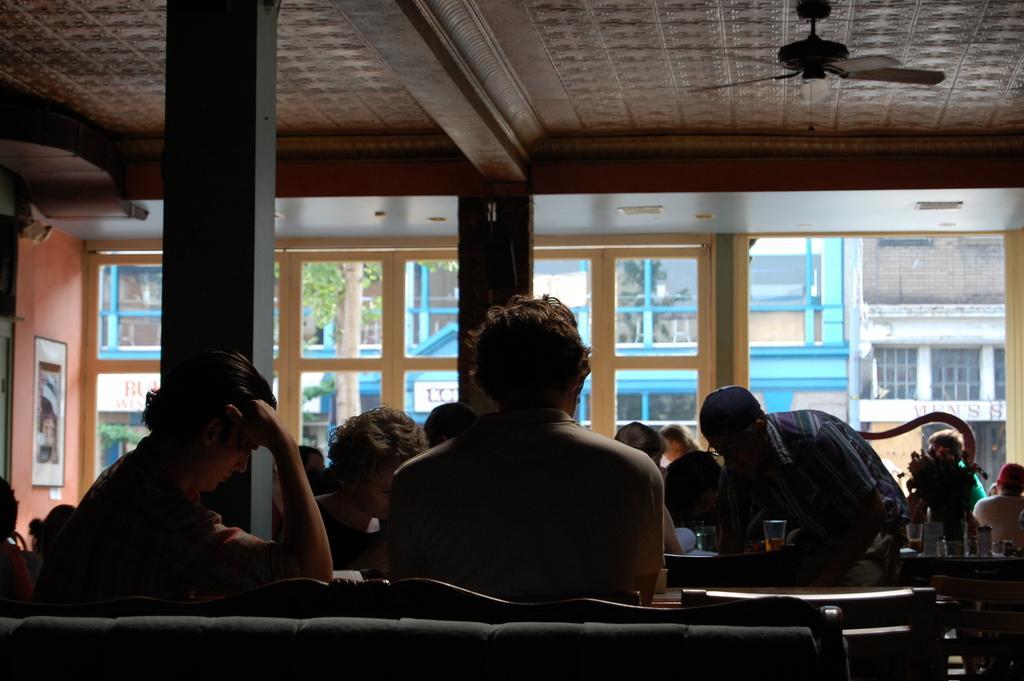Could you give a brief overview of what you see in this image? In this picture we can see few persons sitting on the chairs in front of a table and we cans ee few glasses on the tables. This is a flower vase. On the background we can see a glass windows through which outside view is visible and we can see buildings over there. This is a fan over the ceiling. 